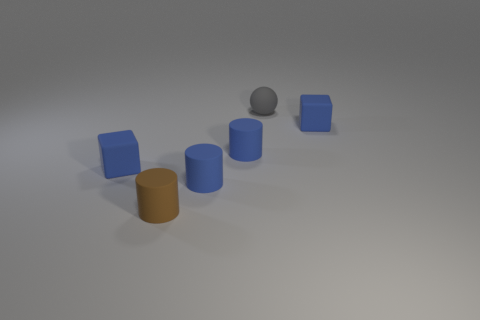Subtract all blue blocks. How many were subtracted if there are1blue blocks left? 1 Subtract all blue rubber cylinders. How many cylinders are left? 1 Add 1 gray rubber spheres. How many objects exist? 7 Subtract all spheres. How many objects are left? 5 Subtract 2 blue blocks. How many objects are left? 4 Subtract all brown cylinders. Subtract all tiny gray spheres. How many objects are left? 4 Add 4 tiny blue things. How many tiny blue things are left? 8 Add 2 yellow metal things. How many yellow metal things exist? 2 